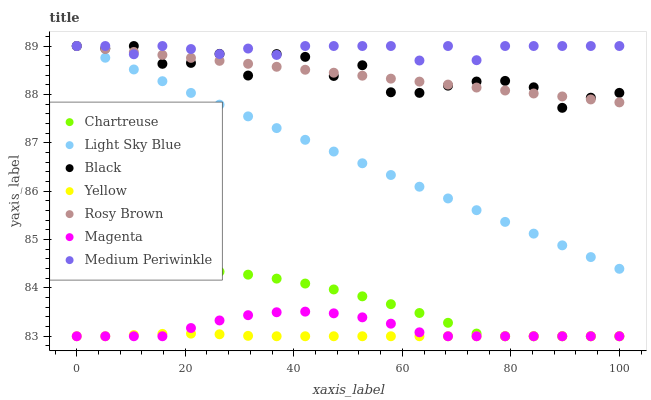Does Yellow have the minimum area under the curve?
Answer yes or no. Yes. Does Medium Periwinkle have the maximum area under the curve?
Answer yes or no. Yes. Does Medium Periwinkle have the minimum area under the curve?
Answer yes or no. No. Does Yellow have the maximum area under the curve?
Answer yes or no. No. Is Rosy Brown the smoothest?
Answer yes or no. Yes. Is Black the roughest?
Answer yes or no. Yes. Is Medium Periwinkle the smoothest?
Answer yes or no. No. Is Medium Periwinkle the roughest?
Answer yes or no. No. Does Yellow have the lowest value?
Answer yes or no. Yes. Does Medium Periwinkle have the lowest value?
Answer yes or no. No. Does Black have the highest value?
Answer yes or no. Yes. Does Yellow have the highest value?
Answer yes or no. No. Is Chartreuse less than Light Sky Blue?
Answer yes or no. Yes. Is Black greater than Chartreuse?
Answer yes or no. Yes. Does Medium Periwinkle intersect Rosy Brown?
Answer yes or no. Yes. Is Medium Periwinkle less than Rosy Brown?
Answer yes or no. No. Is Medium Periwinkle greater than Rosy Brown?
Answer yes or no. No. Does Chartreuse intersect Light Sky Blue?
Answer yes or no. No. 